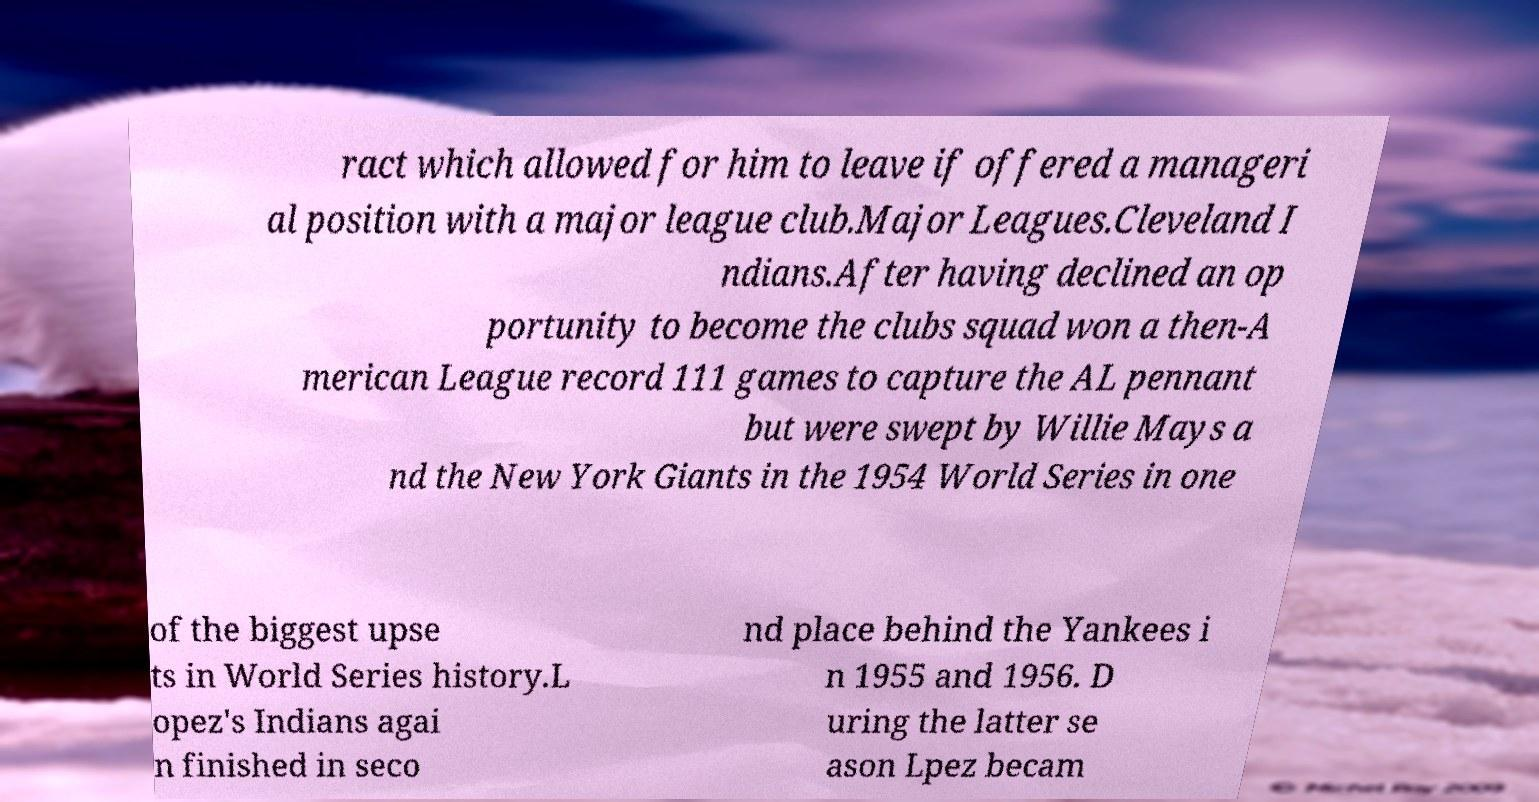There's text embedded in this image that I need extracted. Can you transcribe it verbatim? ract which allowed for him to leave if offered a manageri al position with a major league club.Major Leagues.Cleveland I ndians.After having declined an op portunity to become the clubs squad won a then-A merican League record 111 games to capture the AL pennant but were swept by Willie Mays a nd the New York Giants in the 1954 World Series in one of the biggest upse ts in World Series history.L opez's Indians agai n finished in seco nd place behind the Yankees i n 1955 and 1956. D uring the latter se ason Lpez becam 